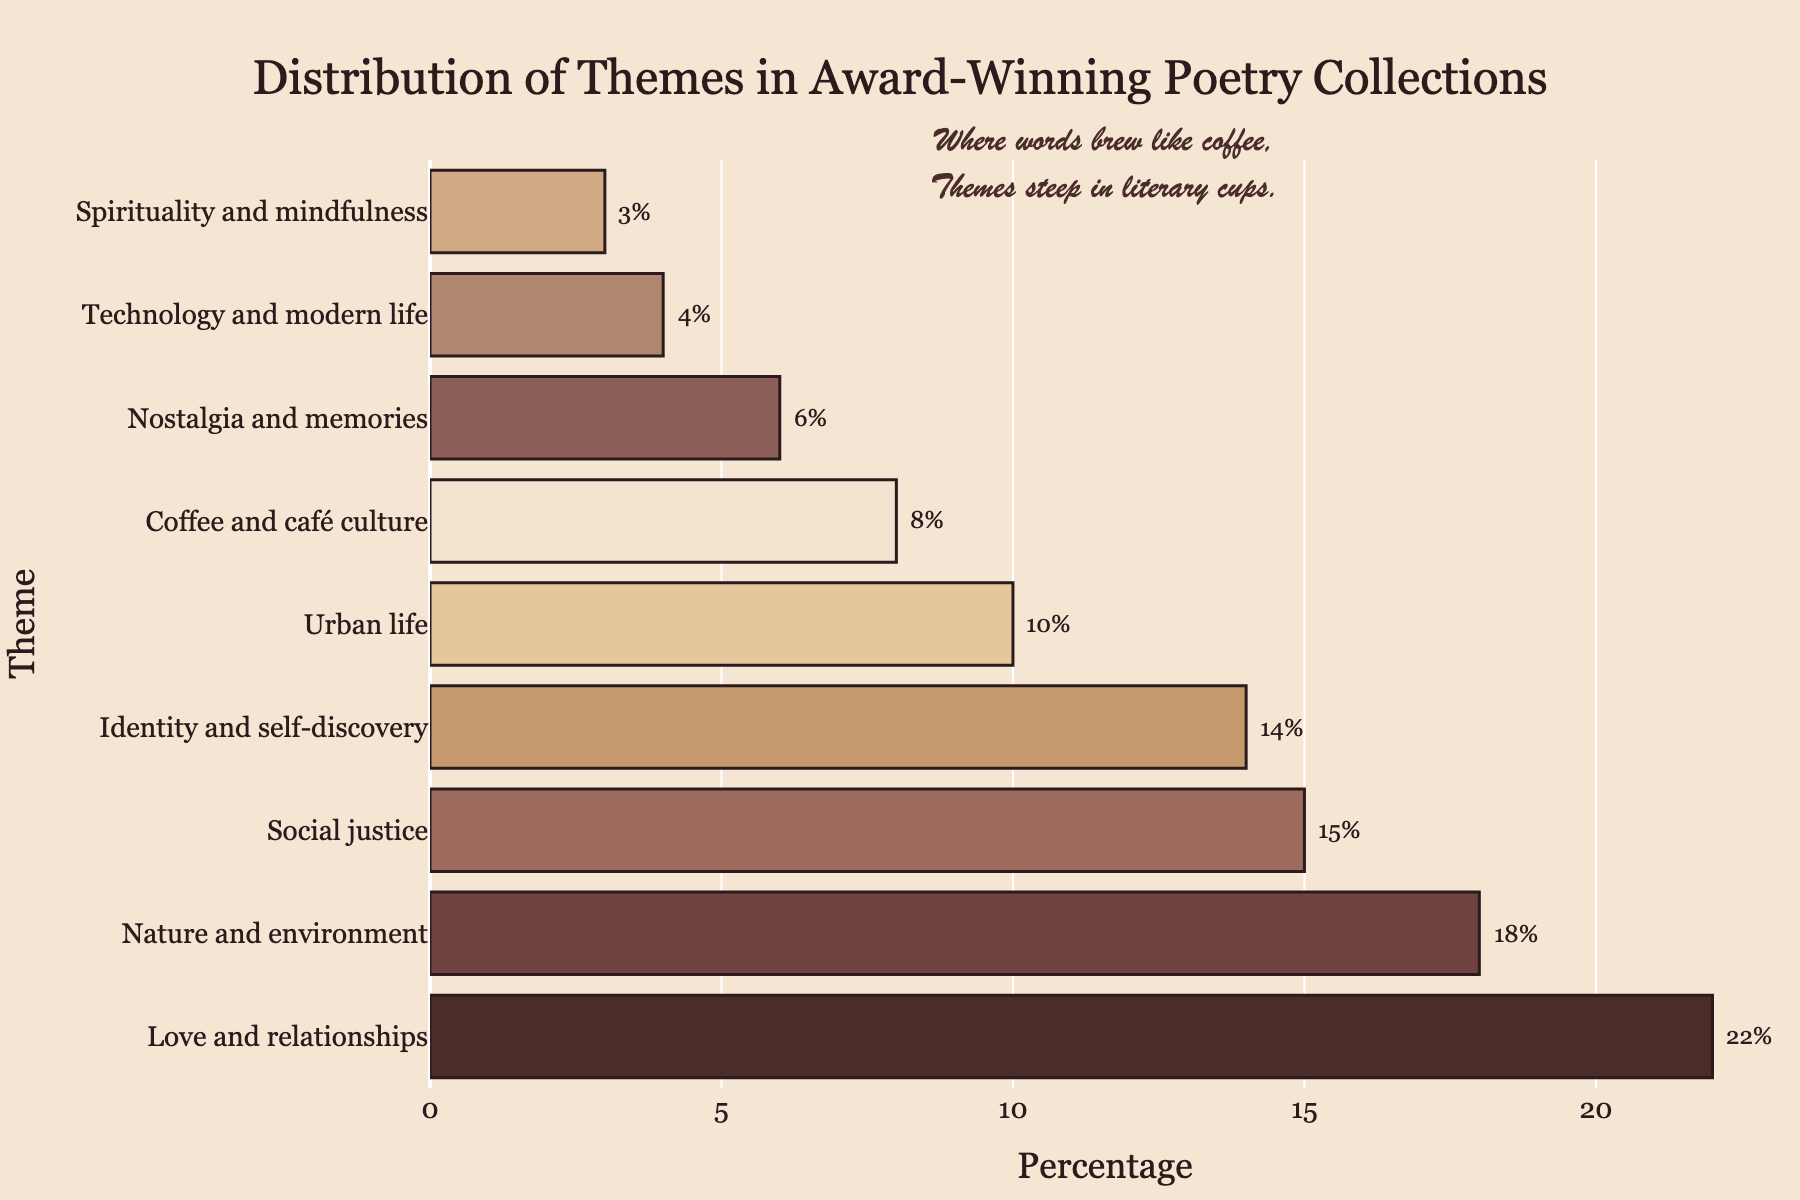Which theme has the highest percentage? "Love and relationships" has the highest percentage. By visually inspecting the lengths of the bars, the bar representing "Love and relationships" extends the furthest, corresponding to 22%.
Answer: "Love and relationships" How does the percentage of "Coffee and café culture" compare to "Social justice"? The percentage of "Coffee and café culture" is 8%, while "Social justice" is 15%. Comparing the values, "Social justice" is higher.
Answer: "Social justice" is higher What is the cumulative percentage of the top three themes? The top three themes are "Love and relationships" (22%), "Nature and environment" (18%), and "Social justice" (15%). Summing these up: 22 + 18 + 15 = 55
Answer: 55% Which theme is represented by the third shortest bar? The third shortest bar corresponds to "Technology and modern life". Visually, it is represented by the fourth-shortest bar at 4%.
Answer: "Technology and modern life" How much higher is the percentage of "Identity and self-discovery" compared to "Nostalgia and memories"? "Identity and self-discovery" is 14%, and "Nostalgia and memories" is 6%. Subtracting these values: 14 - 6 = 8
Answer: 8% What are the two themes with the smallest percentages, and what are their values? The two themes with the smallest percentages are "Technology and modern life" at 4% and "Spirituality and mindfulness" at 3%.
Answer: "Technology and modern life" (4%), "Spirituality and mindfulness" (3%) Calculate the percentage difference between "Urban life" and "Nature and environment". "Urban life" is 10%, and "Nature and environment" is 18%. The difference is calculated as 18 - 10 = 8
Answer: 8% Identify the theme represented by the second darkest bar and state its percentage. The second darkest bar is visually identifiable and corresponds to "Nature and environment". Its percentage is 18%.
Answer: "Nature and environment" (18%) What's the average percentage of all the themes? Sum all the percentages: 22 + 18 + 15 + 14 + 10 + 8 + 6 + 4 + 3 = 100. There are 9 themes, so the average is 100 / 9 ≈ 11.11
Answer: 11.11% 